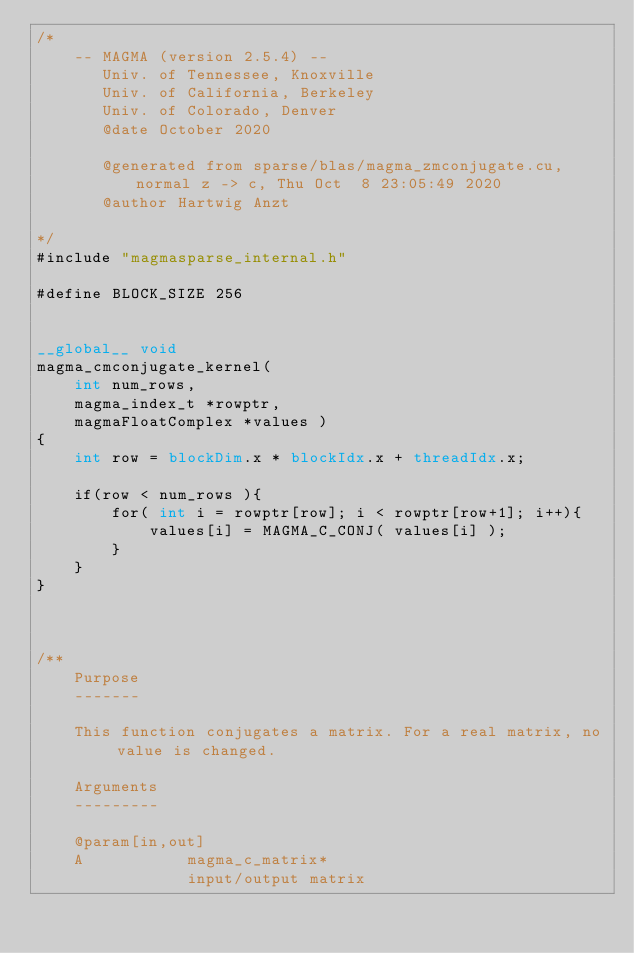Convert code to text. <code><loc_0><loc_0><loc_500><loc_500><_Cuda_>/*
    -- MAGMA (version 2.5.4) --
       Univ. of Tennessee, Knoxville
       Univ. of California, Berkeley
       Univ. of Colorado, Denver
       @date October 2020

       @generated from sparse/blas/magma_zmconjugate.cu, normal z -> c, Thu Oct  8 23:05:49 2020
       @author Hartwig Anzt

*/
#include "magmasparse_internal.h"

#define BLOCK_SIZE 256


__global__ void 
magma_cmconjugate_kernel(  
    int num_rows,
    magma_index_t *rowptr, 
    magmaFloatComplex *values )
{
    int row = blockDim.x * blockIdx.x + threadIdx.x;

    if(row < num_rows ){
        for( int i = rowptr[row]; i < rowptr[row+1]; i++){
            values[i] = MAGMA_C_CONJ( values[i] );
        }
    }
}



/**
    Purpose
    -------

    This function conjugates a matrix. For a real matrix, no value is changed.

    Arguments
    ---------

    @param[in,out]
    A           magma_c_matrix*
                input/output matrix</code> 